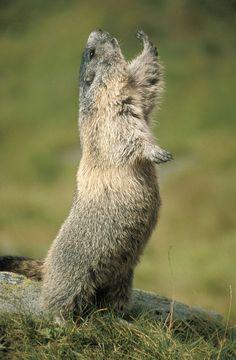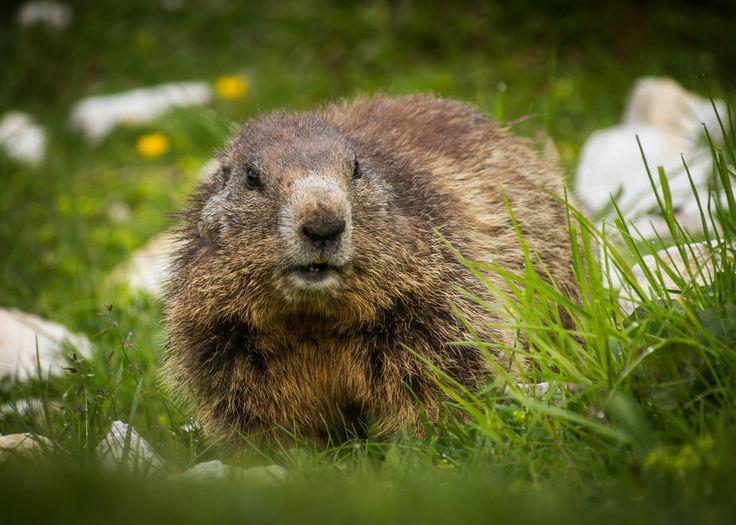The first image is the image on the left, the second image is the image on the right. Given the left and right images, does the statement "There is at least one prairie dog standing on its hind legs." hold true? Answer yes or no. Yes. 